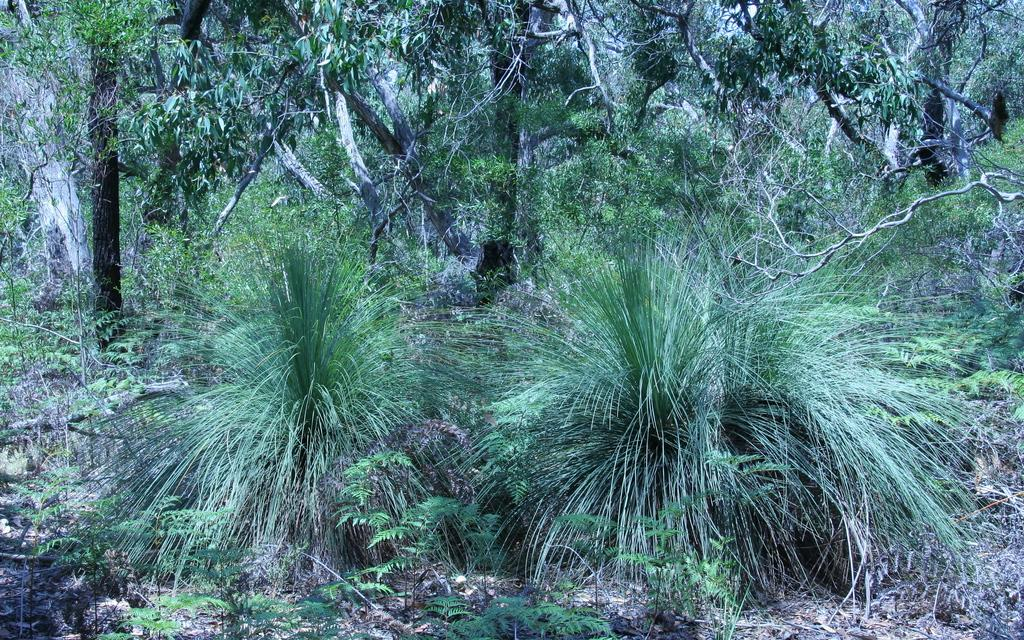What type of vegetation can be seen in the image? There are plants and trees visible in the image. What is the ground covered with in the image? There is grass visible in the image. What type of bait is being used to catch fish in the image? There is no mention of fish or bait in the image; it only features plants, trees, and grass. 